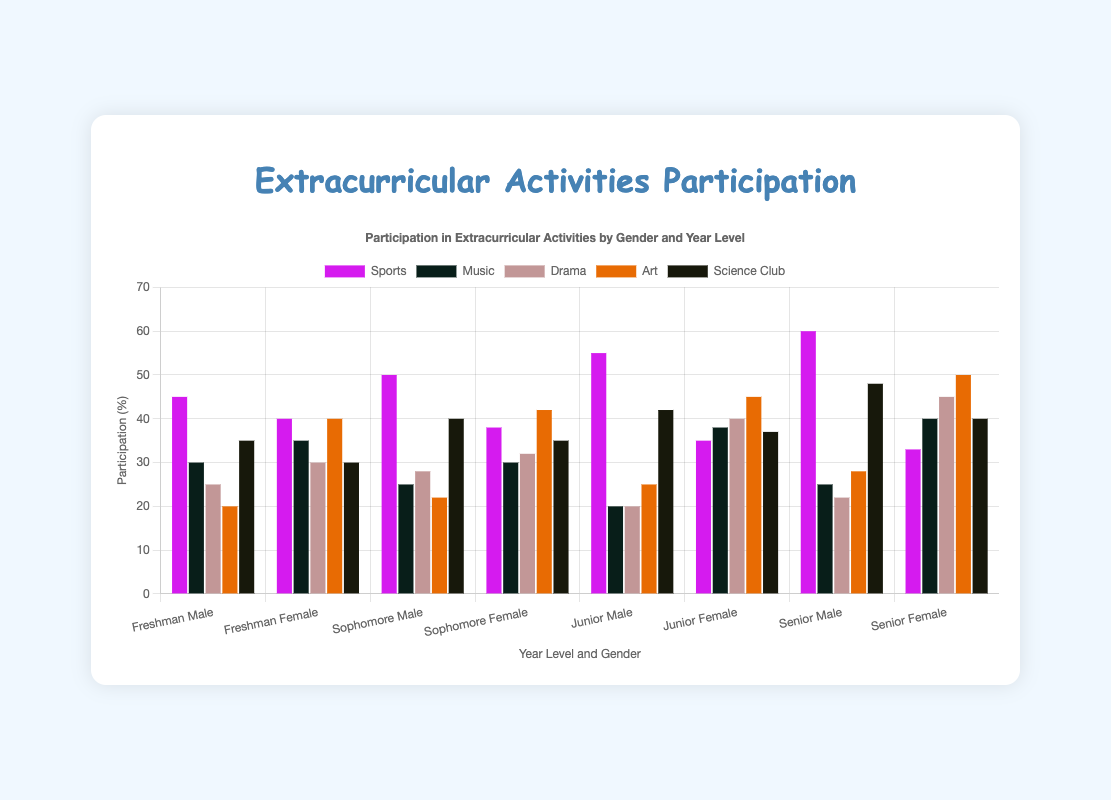What is the participation difference between male and female juniors in Drama? To find the difference, look at the Drama participation percentages for junior males and females. Junior males have a Drama participation of 20%, while junior females have 40%. The difference is 40% - 20% = 20%.
Answer: 20% Which gender participates more in Science Club during their freshman year? Look at the Science Club participation percentages for freshman males and females. Freshman males have 35%, and freshman females have 30%. Freshman males participate more.
Answer: Freshman males Which year level has the highest participation in Sports for males? Look at the Sports participation percentages for males across all year levels: Freshman (45%), Sophomore (50%), Junior (55%), Senior (60%). The highest is for Seniors at 60%.
Answer: Seniors Compare the participation in Art between sophomore males and sophomore females. Which group is higher? Look at the Art participation percentages for sophomore males and females. Sophomore males have 22%, while sophomore females have 42%. Sophomore females have higher participation.
Answer: Sophomore females What is the average participation in Music for all female students? Calculate the average by summing Music participation percentages for females across all years and dividing by the number of data points: (35 + 30 + 38 + 40)/4. The sum is 143, and the average is 143/4 = 35.75%.
Answer: 35.75% What activity do freshman females participate in the most? Look at the participation percentages for each activity for freshman females: Sports (40%), Music (35%), Drama (30%), Art (40%), Science Club (30%). The highest participation for freshman females is tied between Sports and Art at 40%.
Answer: Sports and Art By how much does the participation in Sports for males increase from freshman to senior year? Look at the Sports participation percentages for males in freshman and senior years. Freshman males have 45%, and senior males have 60%. The increase is 60% - 45% = 15%.
Answer: 15% What are the two activities in which senior females participate the most? Look at the participation percentages for each activity for senior females: Sports (33%), Music (40%), Drama (45%), Art (50%), Science Club (40%). The two highest are Art (50%) and Drama (45%).
Answer: Art and Drama Which year level shows the smallest gender gap in Sports participation? Calculate the gender gap for each year by subtracting the female percentage from the male percentage: Freshman (45 - 40 = 5), Sophomore (50 - 38 = 12), Junior (55 - 35 = 20), Senior (60 - 33 = 27). The smallest gap is for Freshmen at 5%.
Answer: Freshman 